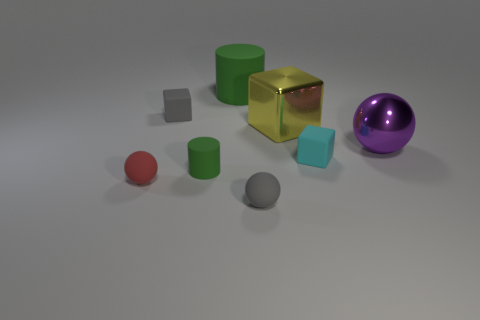Subtract all yellow cylinders. Subtract all yellow spheres. How many cylinders are left? 2 Add 1 big shiny spheres. How many objects exist? 9 Subtract all cylinders. How many objects are left? 6 Add 8 large yellow things. How many large yellow things exist? 9 Subtract 1 gray blocks. How many objects are left? 7 Subtract all green things. Subtract all small green objects. How many objects are left? 5 Add 1 big yellow shiny blocks. How many big yellow shiny blocks are left? 2 